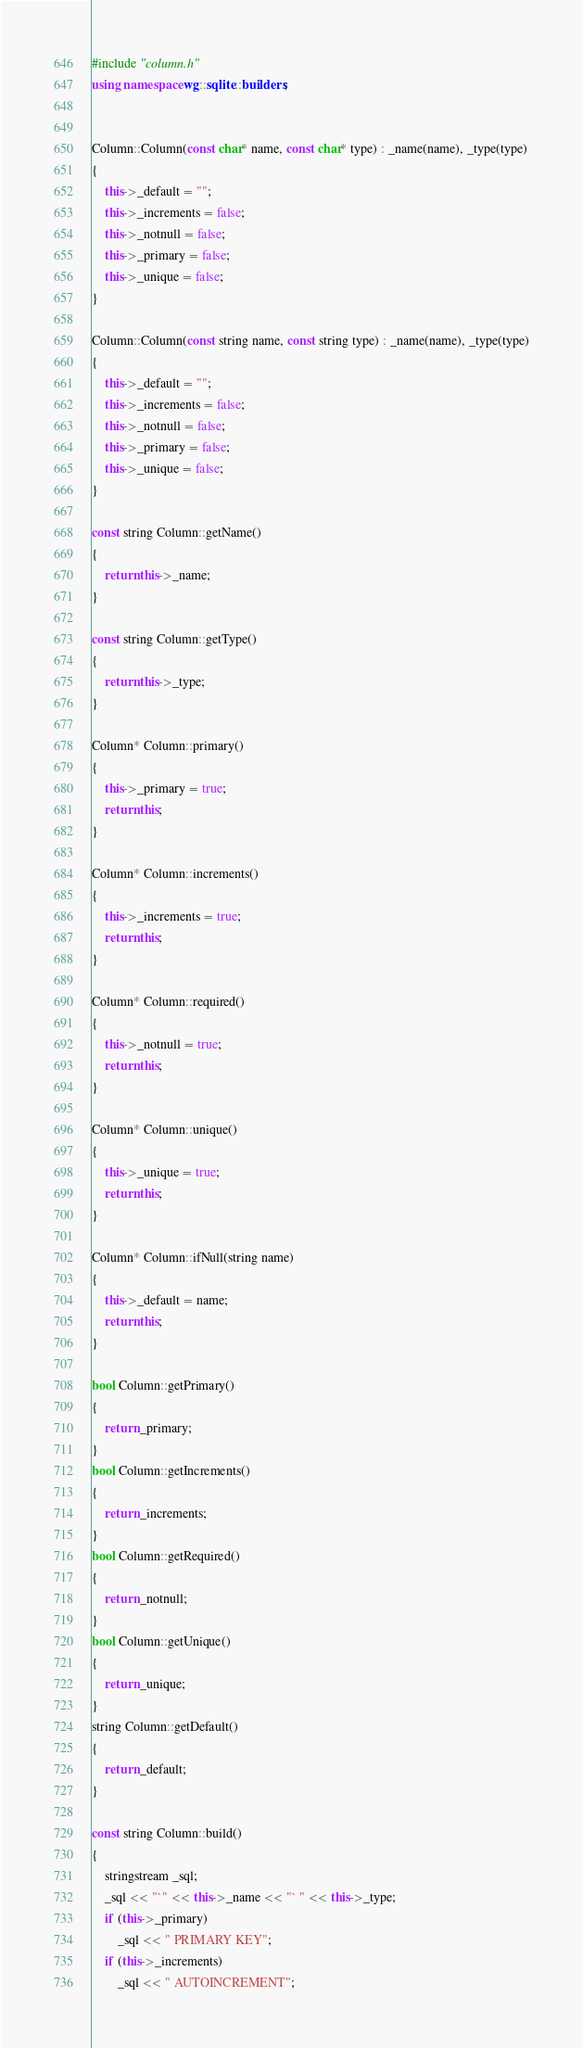Convert code to text. <code><loc_0><loc_0><loc_500><loc_500><_C++_>#include "column.h"
using namespace wg::sqlite::builders;


Column::Column(const char* name, const char* type) : _name(name), _type(type)
{
	this->_default = "";
	this->_increments = false;
	this->_notnull = false;
	this->_primary = false;
	this->_unique = false;
}

Column::Column(const string name, const string type) : _name(name), _type(type)
{
	this->_default = "";
	this->_increments = false;
	this->_notnull = false;
	this->_primary = false;
	this->_unique = false;
}

const string Column::getName()
{
	return this->_name;
}

const string Column::getType()
{
	return this->_type;
}

Column* Column::primary()
{
	this->_primary = true;
	return this;
}

Column* Column::increments()
{
	this->_increments = true;
	return this;
}

Column* Column::required()
{
	this->_notnull = true;
	return this;
}

Column* Column::unique()
{
	this->_unique = true;
	return this;
}

Column* Column::ifNull(string name)
{
	this->_default = name;
	return this;
}

bool Column::getPrimary()
{
	return _primary;
}
bool Column::getIncrements()
{
	return _increments;
}
bool Column::getRequired()
{
	return _notnull;
}
bool Column::getUnique()
{
	return _unique;
}
string Column::getDefault()
{
	return _default;
}

const string Column::build()
{
	stringstream _sql;
	_sql << "`" << this->_name << "` " << this->_type;
	if (this->_primary)
		_sql << " PRIMARY KEY";
	if (this->_increments)
		_sql << " AUTOINCREMENT";</code> 